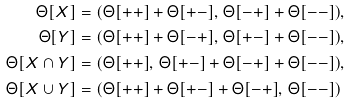<formula> <loc_0><loc_0><loc_500><loc_500>\Theta [ X ] & = ( \Theta [ + + ] + \Theta [ + - ] , \, \Theta [ - + ] + \Theta [ - - ] ) , \\ \Theta [ Y ] & = ( \Theta [ + + ] + \Theta [ - + ] , \, \Theta [ + - ] + \Theta [ - - ] ) , \\ \Theta [ X \cap Y ] & = ( \Theta [ + + ] , \, \Theta [ + - ] + \Theta [ - + ] + \Theta [ - - ] ) , \\ \Theta [ X \cup Y ] & = ( \Theta [ + + ] + \Theta [ + - ] + \Theta [ - + ] , \, \Theta [ - - ] )</formula> 